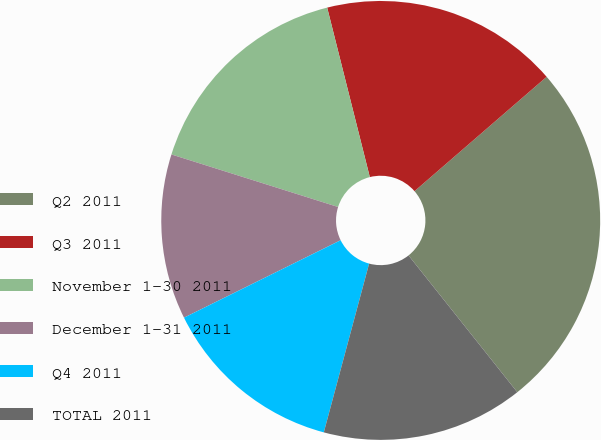Convert chart. <chart><loc_0><loc_0><loc_500><loc_500><pie_chart><fcel>Q2 2011<fcel>Q3 2011<fcel>November 1-30 2011<fcel>December 1-31 2011<fcel>Q4 2011<fcel>TOTAL 2011<nl><fcel>25.67%<fcel>17.57%<fcel>16.22%<fcel>12.17%<fcel>13.52%<fcel>14.87%<nl></chart> 